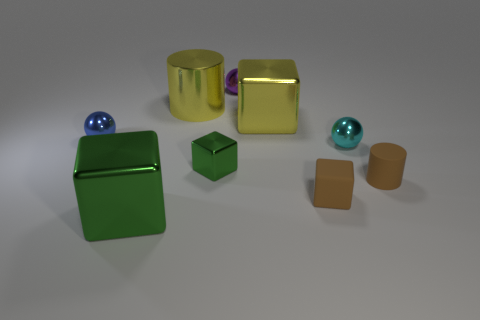How many green cubes must be subtracted to get 1 green cubes? 1 Subtract all cylinders. How many objects are left? 7 Add 5 tiny rubber cylinders. How many tiny rubber cylinders are left? 6 Add 4 cyan things. How many cyan things exist? 5 Subtract 0 blue cylinders. How many objects are left? 9 Subtract all small blue metallic objects. Subtract all purple shiny objects. How many objects are left? 7 